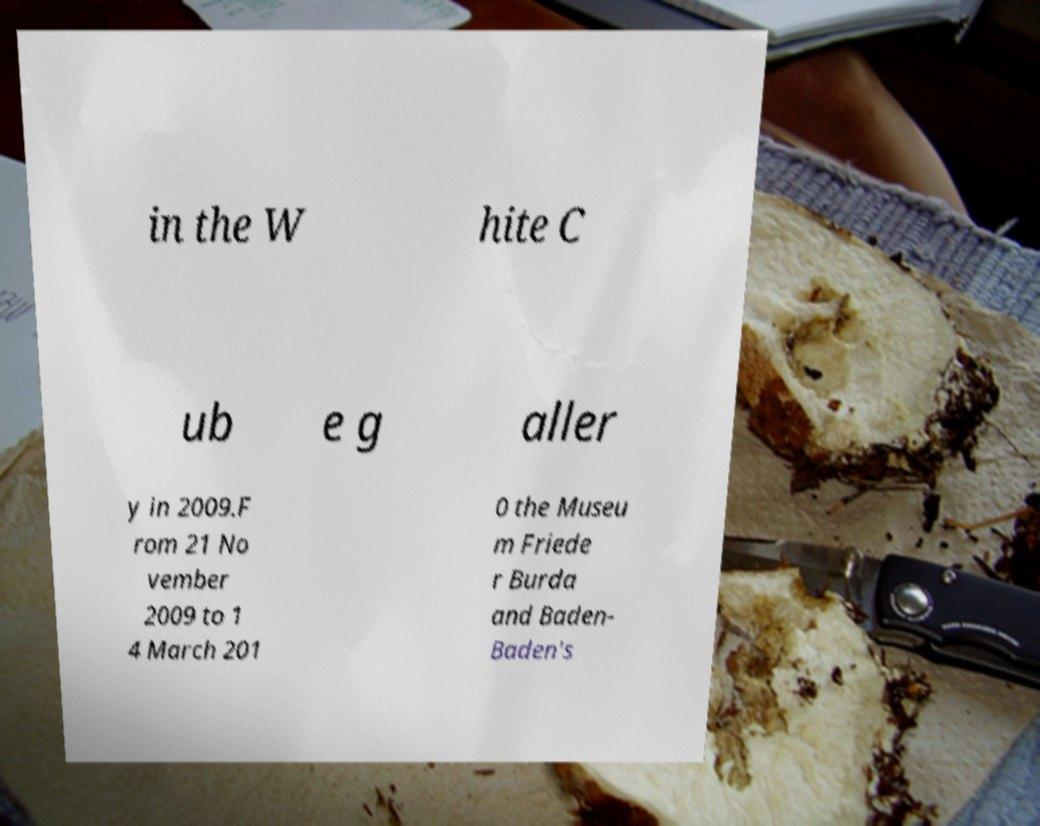Could you assist in decoding the text presented in this image and type it out clearly? in the W hite C ub e g aller y in 2009.F rom 21 No vember 2009 to 1 4 March 201 0 the Museu m Friede r Burda and Baden- Baden's 